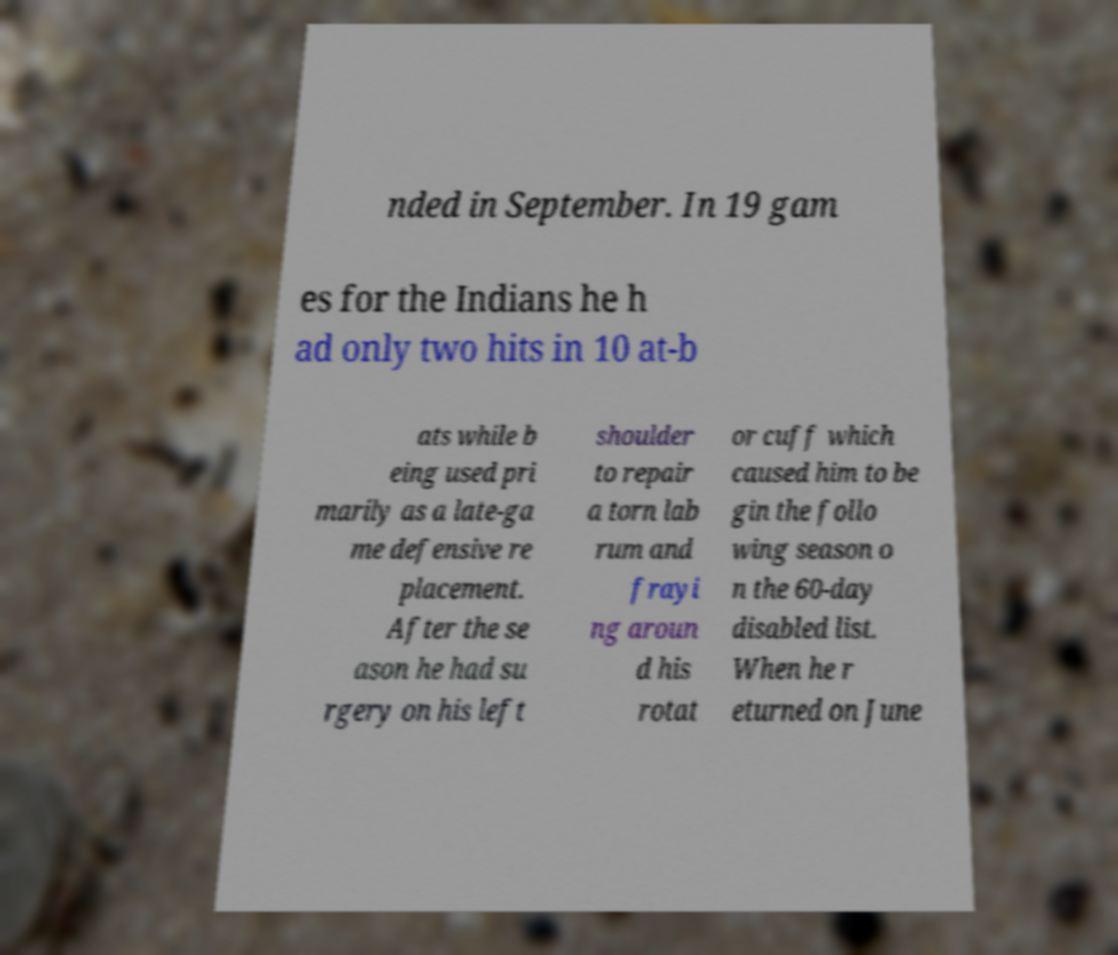Can you read and provide the text displayed in the image?This photo seems to have some interesting text. Can you extract and type it out for me? nded in September. In 19 gam es for the Indians he h ad only two hits in 10 at-b ats while b eing used pri marily as a late-ga me defensive re placement. After the se ason he had su rgery on his left shoulder to repair a torn lab rum and frayi ng aroun d his rotat or cuff which caused him to be gin the follo wing season o n the 60-day disabled list. When he r eturned on June 